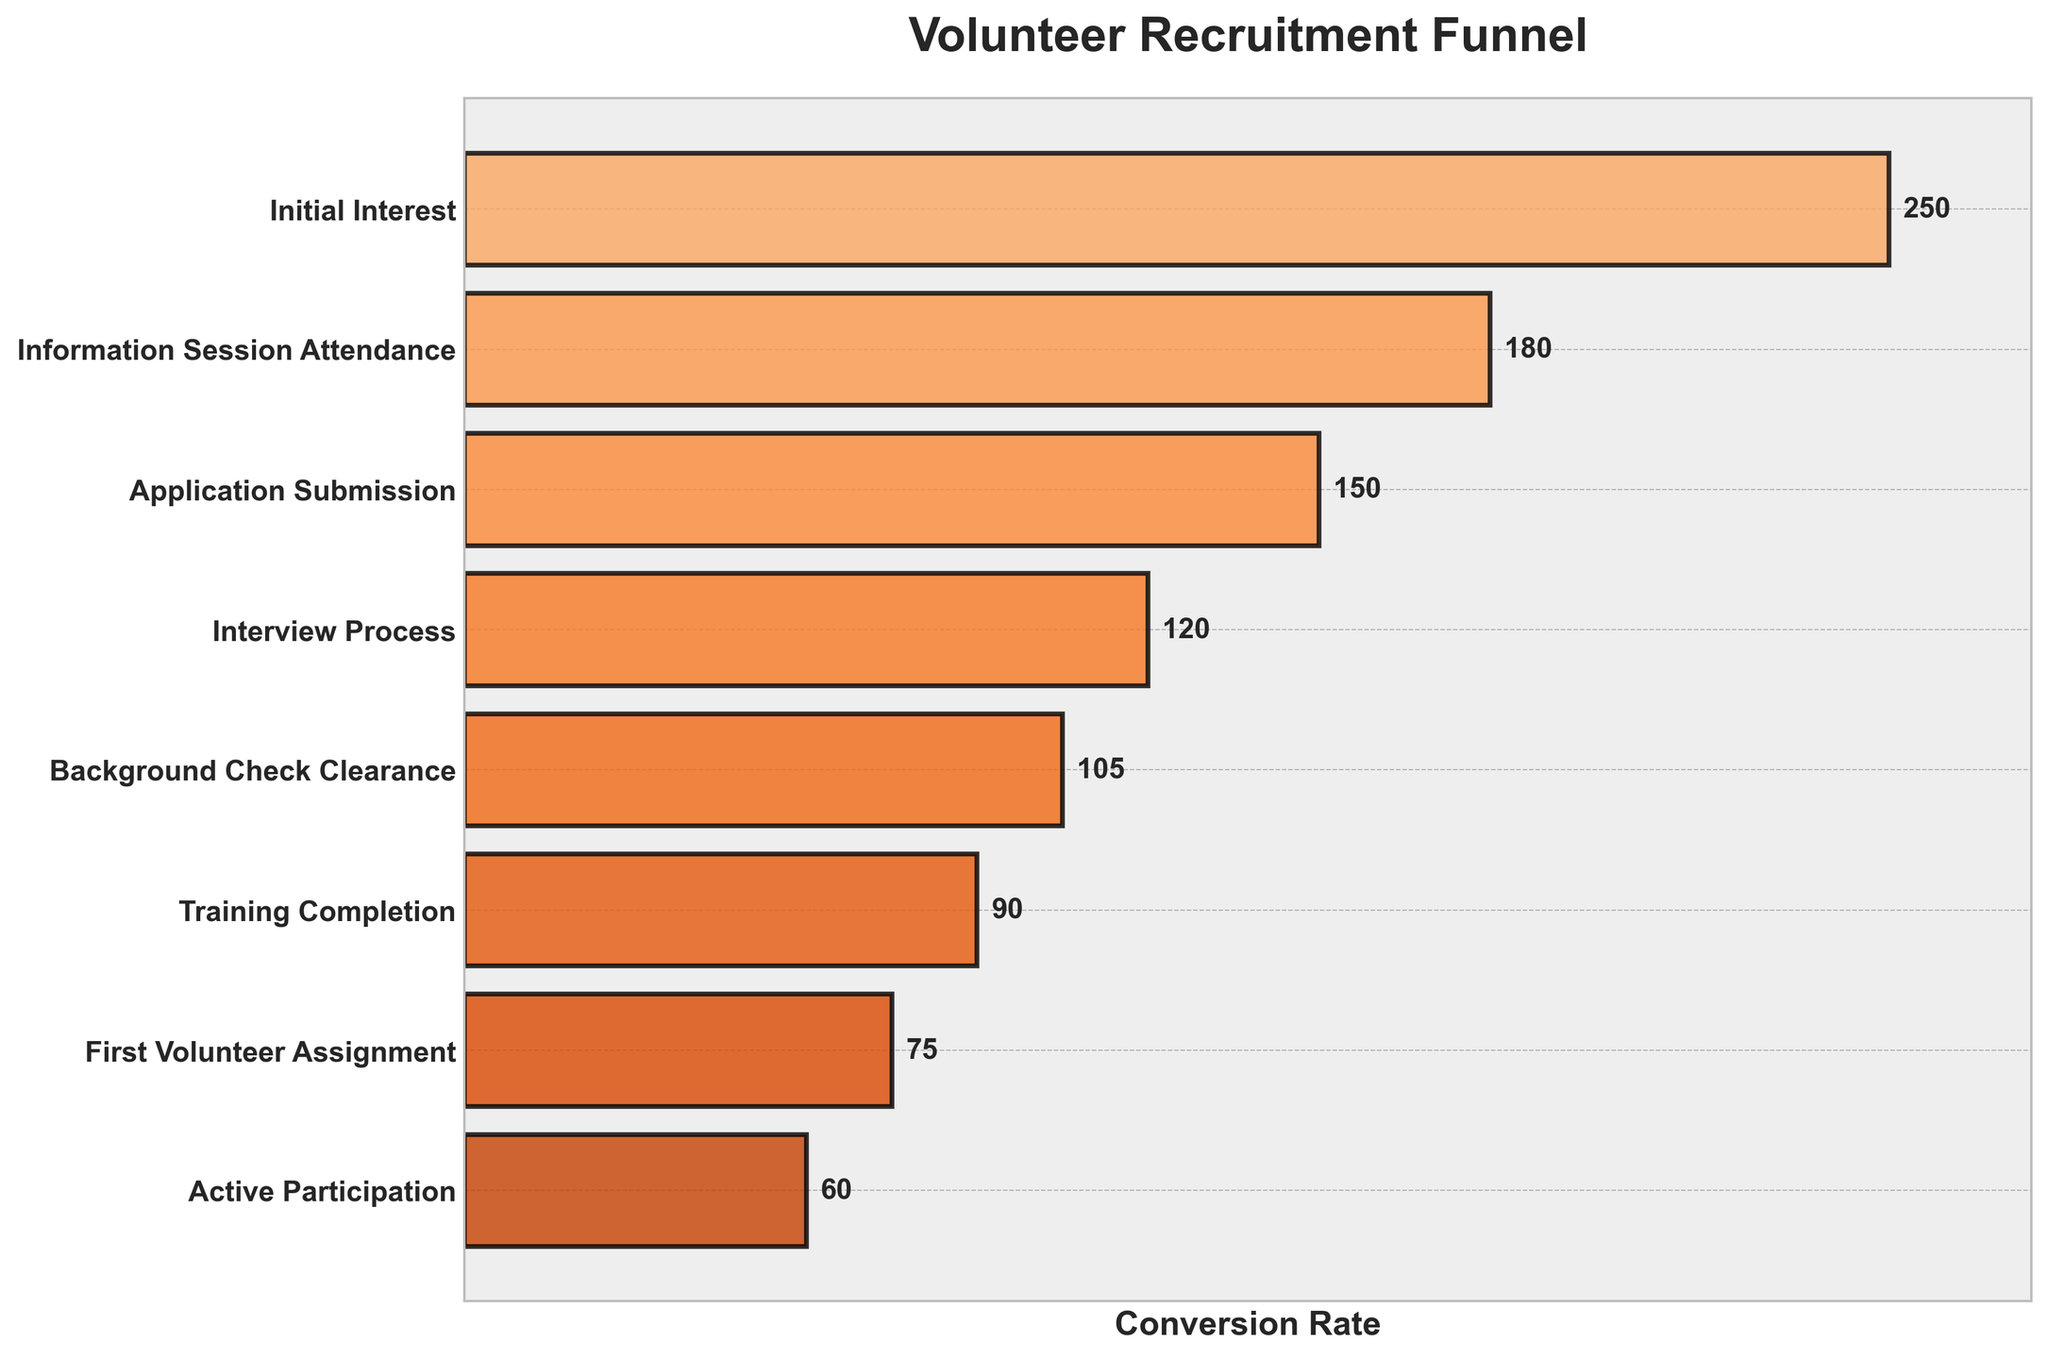How many volunteers attended the Information Session? Look at the bar corresponding to "Information Session Attendance" and read the value label directly.
Answer: 180 Which stage has the highest number of volunteers? The longest bar in the chart corresponds to the "Initial Interest" stage.
Answer: Initial Interest What is the total number of volunteers who completed the Training Completion stage and the First Volunteer Assignment stage? Add the numbers for "Training Completion" and "First Volunteer Assignment" stages: 90 + 75
Answer: 165 By how much did the number of volunteers decrease from the Application Submission stage to the Interview Process stage? Subtract the number of volunteers in the "Interview Process" stage from the "Application Submission" stage: 150 - 120
Answer: 30 What percentage of volunteers who attended the Information Session moved on to submit an application? Divide the number of volunteers at the "Application Submission" stage by the number at the "Information Session Attendance" stage and multiply by 100: (150 / 180) * 100
Answer: 83.33% Compare the number of volunteers at the Initial Interest stage to those at the Application Submission stage. Which stage has more volunteers and by how much? Subtract the number of volunteers in the "Application Submission" stage from the "Initial Interest" stage: 250 - 150. The "Initial Interest" stage has more volunteers.
Answer: Initial Interest, 100 What proportion of the volunteers who began with Initial Interest reached Active Participation? Divide the number of volunteers at the "Active Participation" stage by the number at the "Initial Interest" stage and multiply by 100: (60 / 250) * 100
Answer: 24% What is the average number of volunteers across all stages? Sum the number of volunteers for all stages and divide by the number of stages: (250 + 180 + 150 + 120 + 105 + 90 + 75 + 60) / 8
Answer: 128.75 What is the difference in the number of volunteers who completed the Background Check Clearance stage and those who achieved Active Participation? Subtract the number of volunteers in the "Active Participation" stage from the "Background Check Clearance" stage: 105 - 60
Answer: 45 Which two stages have the biggest drop in the number of volunteers? Find the difference between each pair of consecutive stages and identify the stages with the biggest drop: Initial Interest to Information Session (250-180=70), Information Session to Application Submission (180-150=30), Application Submission to Interview Process (150-120=30), Interview Process to Background Check Clearance (120-105=15), Background Check to Training Completion (105-90=15), Training Completion to First Volunteer Assignment (90-75=15), First Volunteer Assignment to Active Participation (75-60=15). The biggest drop is from Initial Interest to Information Session.
Answer: Initial Interest to Information Session 